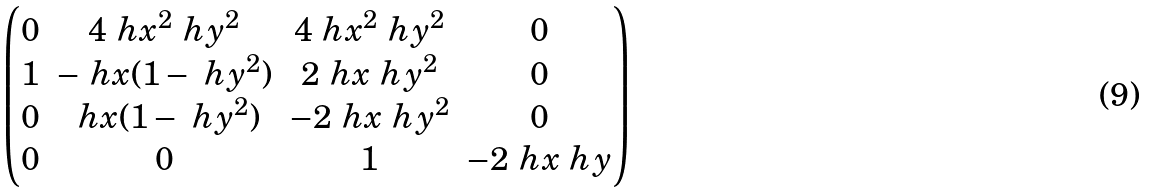<formula> <loc_0><loc_0><loc_500><loc_500>\begin{pmatrix} 0 & 4 \ h x ^ { 2 } \ h y ^ { 2 } & 4 \ h x ^ { 2 } \ h y ^ { 2 } & 0 \\ 1 & - \ h x ( 1 - \ h y ^ { 2 } ) & 2 \ h x \ h y ^ { 2 } & 0 \\ 0 & \ h x ( 1 - \ h y ^ { 2 } ) & - 2 \ h x \ h y ^ { 2 } & 0 \\ 0 & 0 & 1 & - 2 \ h x \ h y \end{pmatrix}</formula> 